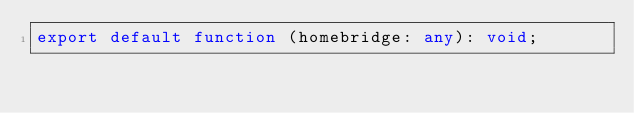Convert code to text. <code><loc_0><loc_0><loc_500><loc_500><_TypeScript_>export default function (homebridge: any): void;
</code> 